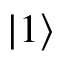Convert formula to latex. <formula><loc_0><loc_0><loc_500><loc_500>| 1 \rangle</formula> 